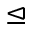<formula> <loc_0><loc_0><loc_500><loc_500>\triangleleft e q</formula> 